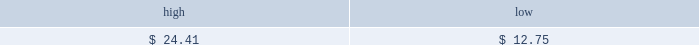Table of contents part ii price range our common stock commenced trading on the nasdaq national market under the symbol 201cmktx 201d on november 5 , 2004 .
Prior to that date , there was no public market for our common stock .
On november 4 , 2004 , the registration statement relating to our initial public offering was declared effective by the sec .
The high and low bid information for our common stock , as reported by nasdaq , was as follows : on march 28 , 2005 , the last reported closing price of our common stock on the nasdaq national market was $ 10.26 .
Holders there were approximately 188 holders of record of our common stock as of march 28 , 2005 .
Dividend policy we have not declared or paid any cash dividends on our capital stock since our inception .
We intend to retain future earnings to finance the operation and expansion of our business and do not anticipate paying any cash dividends in the foreseeable future .
In the event we decide to declare dividends on our common stock in the future , such declaration will be subject to the discretion of our board of directors .
Our board may take into account such matters as general business conditions , our financial results , capital requirements , contractual , legal , and regulatory restrictions on the payment of dividends by us to our stockholders or by our subsidiaries to us and any such other factors as our board may deem relevant .
Use of proceeds on november 4 , 2004 , the registration statement relating to our initial public offering ( no .
333-112718 ) was declared effective .
We received net proceeds from the sale of the shares of our common stock in the offering of $ 53.9 million , at an initial public offering price of $ 11.00 per share , after deducting underwriting discounts and commissions and estimated offering expenses .
Additionally , prior to the closing of the initial public offering , all outstanding shares of convertible preferred stock were converted into 14484493 shares of common stock and 4266310 shares of non-voting common stock .
The underwriters for our initial public offering were credit suisse first boston llc , j.p .
Morgan securities inc. , banc of america securities llc , bear , stearns & co .
Inc .
And ubs securities llc .
All of the underwriters are affiliates of some of our broker-dealer clients and affiliates of some our institutional investor clients .
In addition , affiliates of all the underwriters are stockholders of ours .
Except for salaries , and reimbursements for travel expenses and other out-of-pocket costs incurred in the ordinary course of business , none of the proceeds from the offering have been paid by us , directly or indirectly , to any of our directors or officers or any of their associates , or to any persons owning ten percent or more of our outstanding stock or to any of our affiliates .
As of december 31 , 2004 , we have not used any of the net proceeds from the initial public offering for product development costs , sales and marketing activities and working capital .
We have invested the proceeds from the offering in cash and cash equivalents and short-term marketable securities pending their use for these or other purposes .
Item 5 .
Market for registrant 2019s common equity , related stockholder matters and issuer purchases of equity securities november 5 , 2004 december 31 , 2004 .

What was the difference between the high and low share price for the period? 
Computations: (24.41 - 12.75)
Answer: 11.66. 